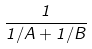Convert formula to latex. <formula><loc_0><loc_0><loc_500><loc_500>\frac { 1 } { 1 / A + 1 / B }</formula> 